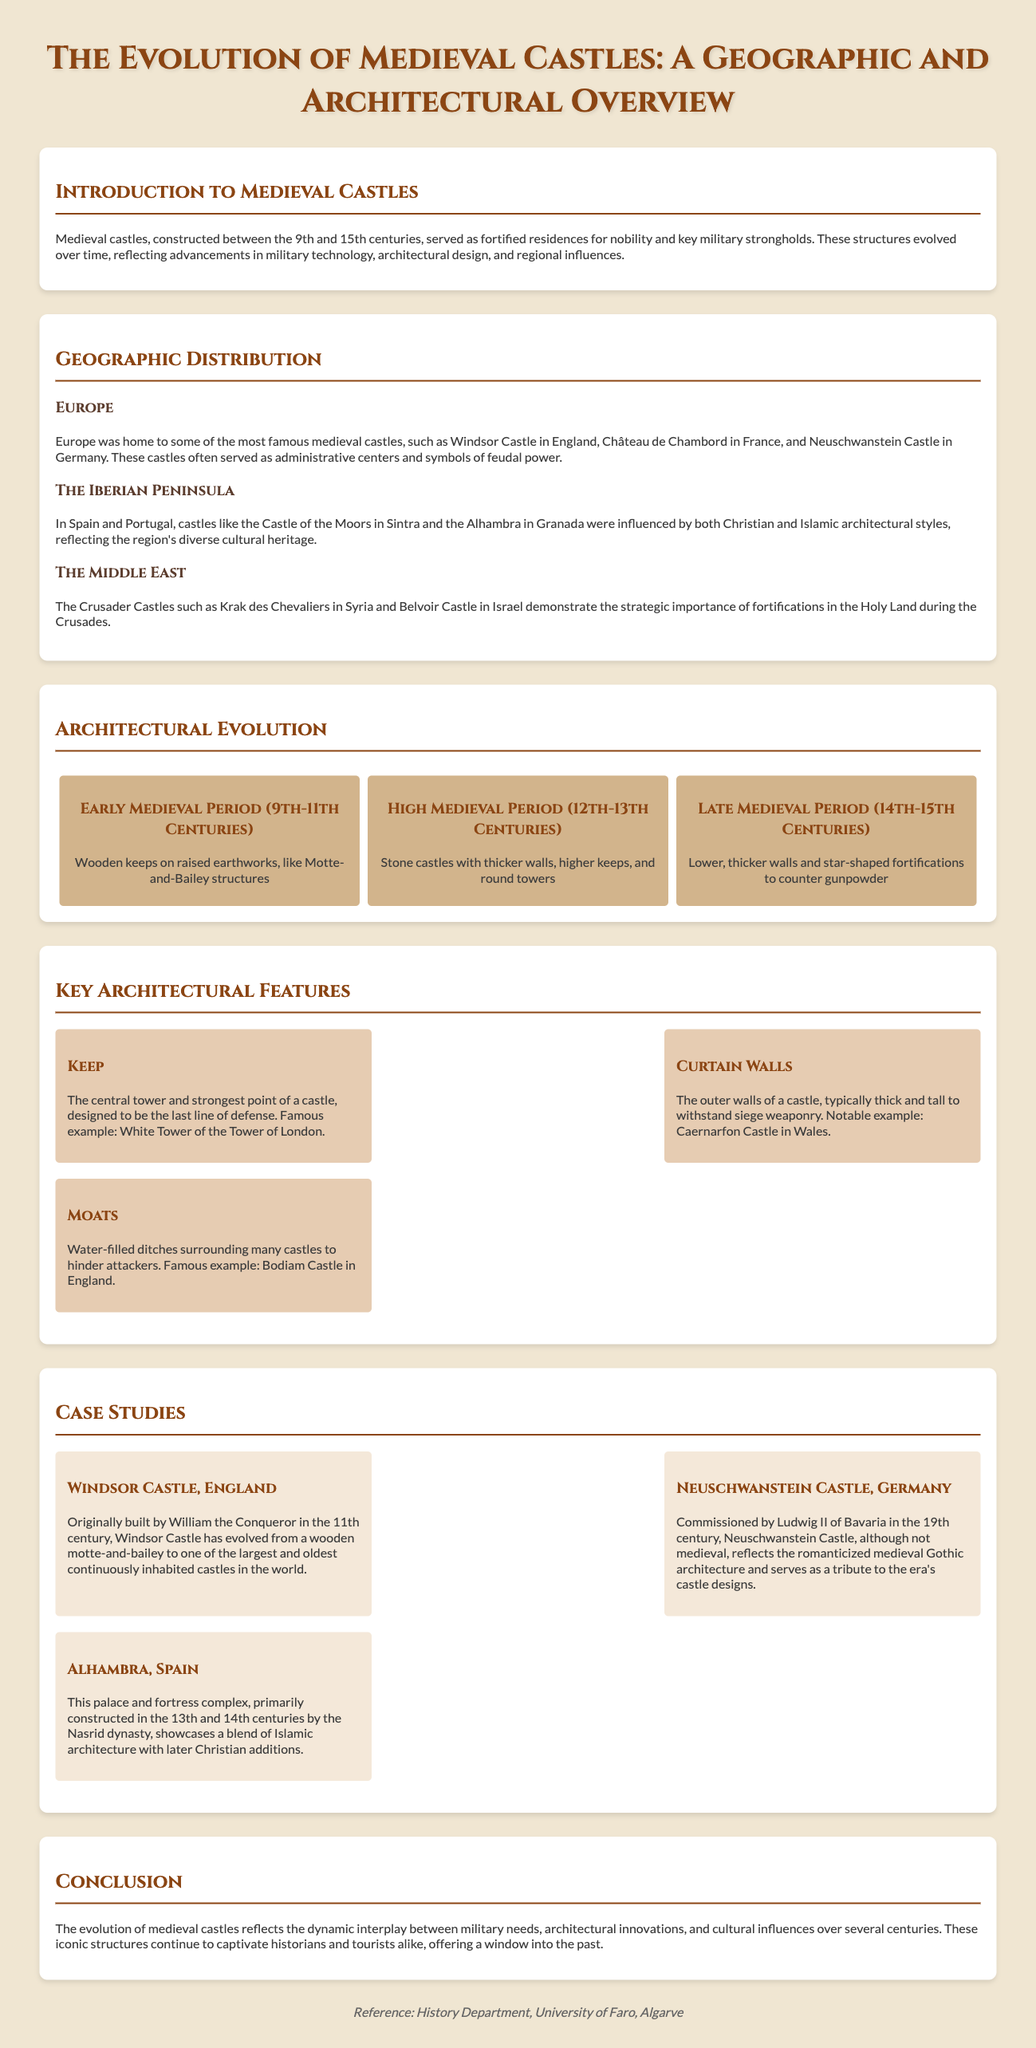What centuries did medieval castles primarily span? The document states that medieval castles were constructed between the 9th and 15th centuries.
Answer: 9th to 15th centuries Which castle is mentioned as a famous example in England? The document lists Windsor Castle in England as a famous medieval castle.
Answer: Windsor Castle What type of walls are described as the outer walls of a castle? The outer walls of a castle are referred to as curtain walls in the document.
Answer: Curtain walls Who commissioned Neuschwanstein Castle? The document says that Neuschwanstein Castle was commissioned by Ludwig II of Bavaria.
Answer: Ludwig II of Bavaria What architectural feature is designed to be the last line of defense? According to the document, the keep is designed to be the last line of defense in a castle.
Answer: Keep What is a significant change in castle architecture during the Late Medieval Period? The document mentions that lower, thicker walls and star-shaped fortifications were used to counter gunpowder.
Answer: Lower, thicker walls and star-shaped fortifications In which region is the Castle of the Moors located? The Castle of the Moors is located in Sintra, Portugal, as stated in the document.
Answer: Sintra What structure evolved from a wooden motte-and-bailey to a stone castle in England? The document specifically mentions Windsor Castle evolving from a wooden motte-and-bailey.
Answer: Windsor Castle What architectural style influences the Alhambra? The document states that the Alhambra reflects a blend of Islamic architecture with later Christian additions.
Answer: Islamic architecture 